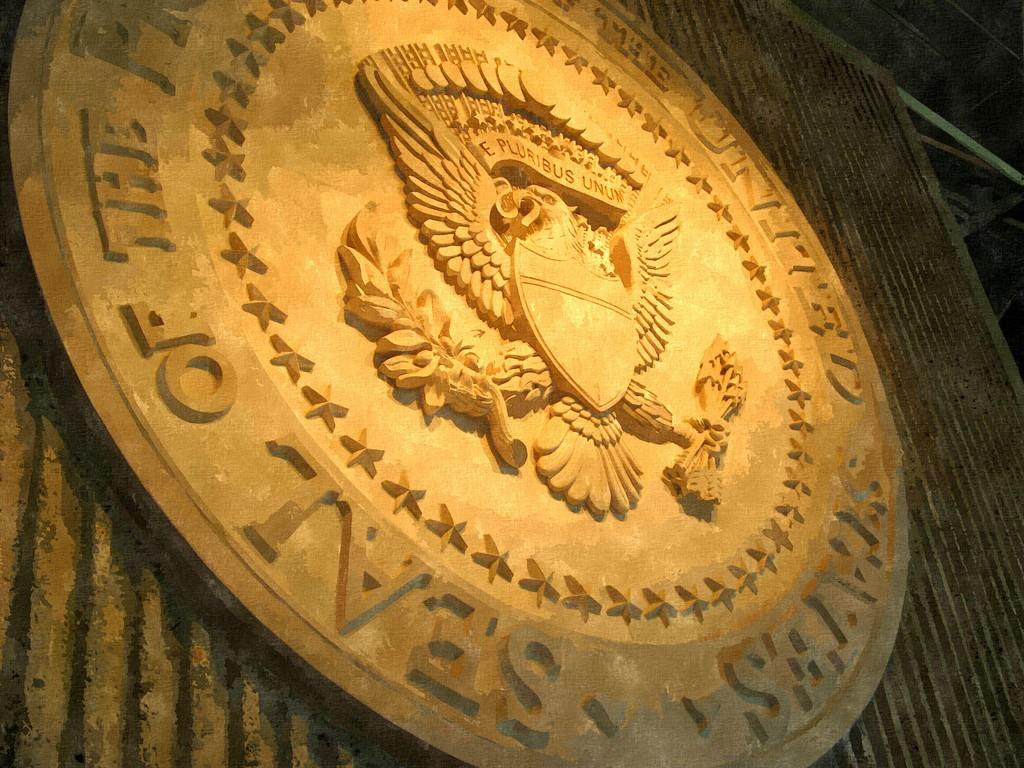<image>
Share a concise interpretation of the image provided. Symbol on a wall with an eagle in the middle and the word "E Pluribus Unun" on top. 